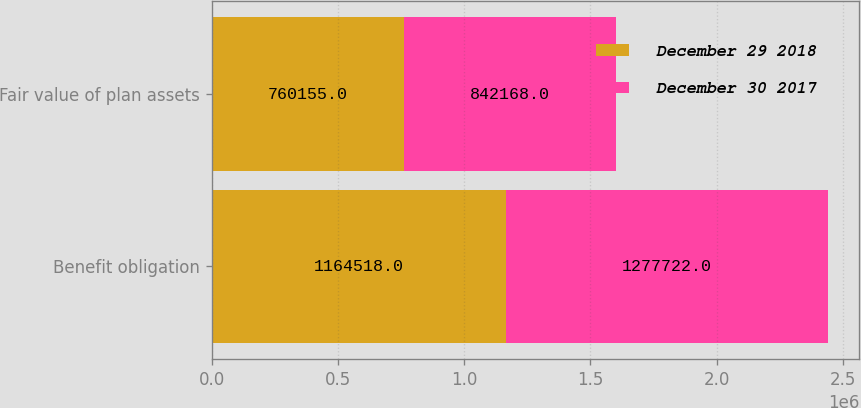Convert chart to OTSL. <chart><loc_0><loc_0><loc_500><loc_500><stacked_bar_chart><ecel><fcel>Benefit obligation<fcel>Fair value of plan assets<nl><fcel>December 29 2018<fcel>1.16452e+06<fcel>760155<nl><fcel>December 30 2017<fcel>1.27772e+06<fcel>842168<nl></chart> 